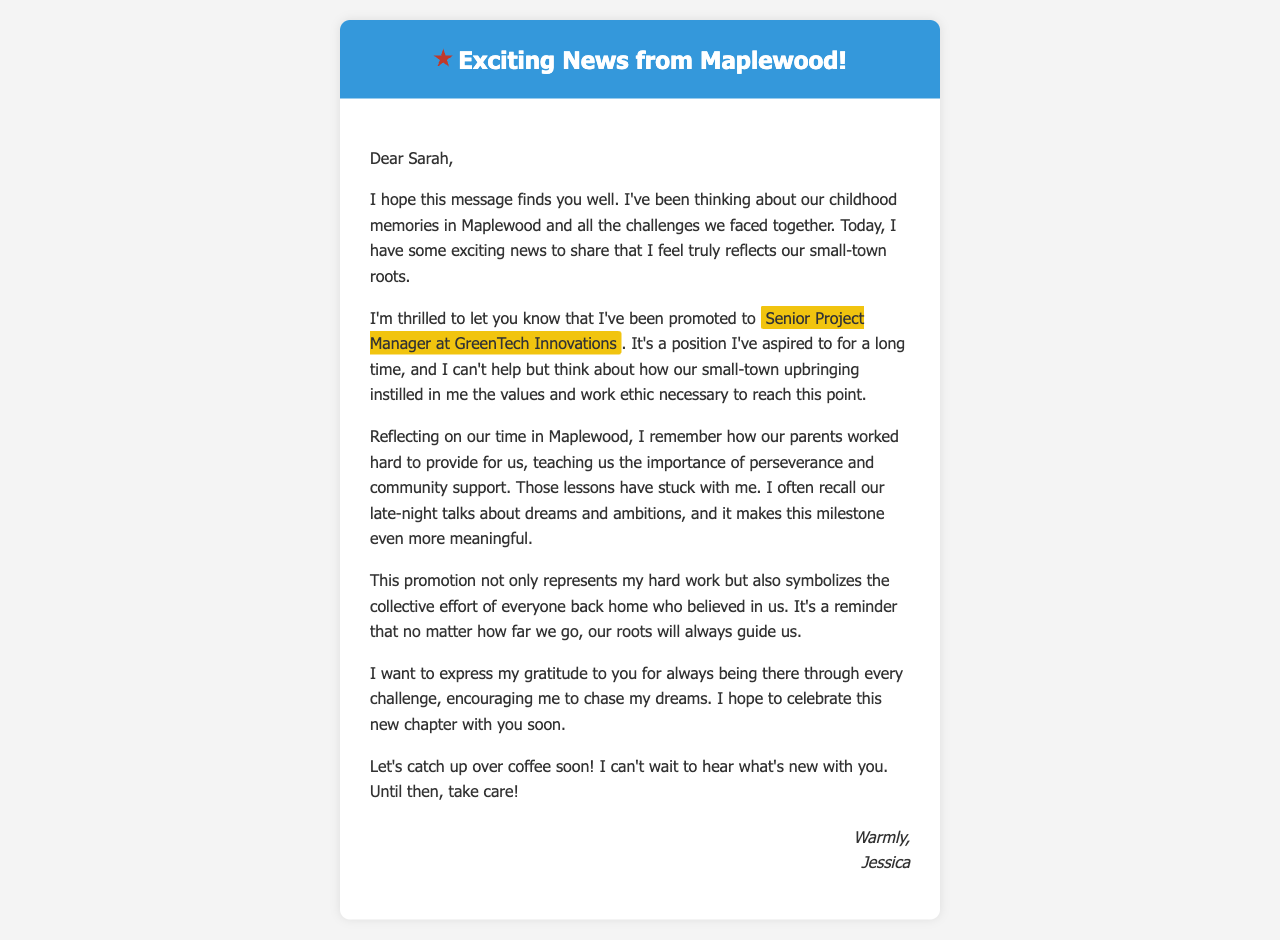what is the name of the sender? The sender of the email is Jessica, as mentioned in the signature at the bottom of the email.
Answer: Jessica what is the new position that Jessica has been promoted to? The email states that Jessica has been promoted to Senior Project Manager at GreenTech Innovations.
Answer: Senior Project Manager at GreenTech Innovations what does the promotion symbolize for Jessica? The promotion symbolizes the collective effort of everyone back home who believed in them, as highlighted in Jessica's reflections.
Answer: Collective effort of everyone back home what key value does Jessica connect to her small-town roots? Jessica connects the value of perseverance to her small-town upbringing, as she recalls the lessons from her parents.
Answer: Perseverance who is the recipient of the email? The recipient of the email is Sarah, as addressed at the beginning of the email.
Answer: Sarah what does Jessica want to do soon? Jessica wants to catch up over coffee to celebrate her new chapter and learn about what's new with Sarah.
Answer: Catch up over coffee what specific memory does Jessica mention about their childhood? Jessica mentions late-night talks about dreams and ambitions as a significant memory from their childhood in Maplewood.
Answer: Late-night talks about dreams and ambitions what emotional tone does the email convey? The email conveys a heartfelt and grateful tone, reflecting Jessica's appreciation for her support system.
Answer: Heartfelt and grateful 